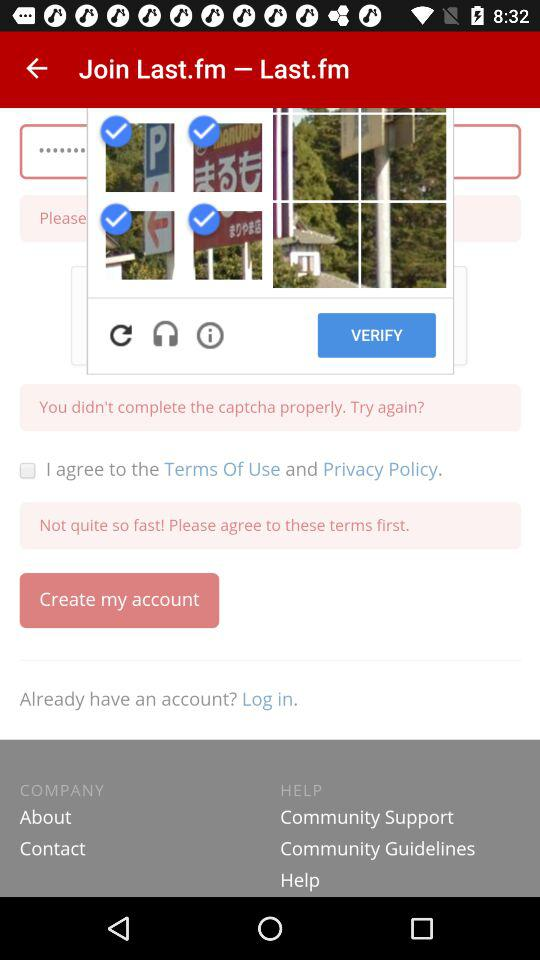What is the status of the option that includes agreement to the “Terms of Use” and “Privacy Policy”? The status is "off". 